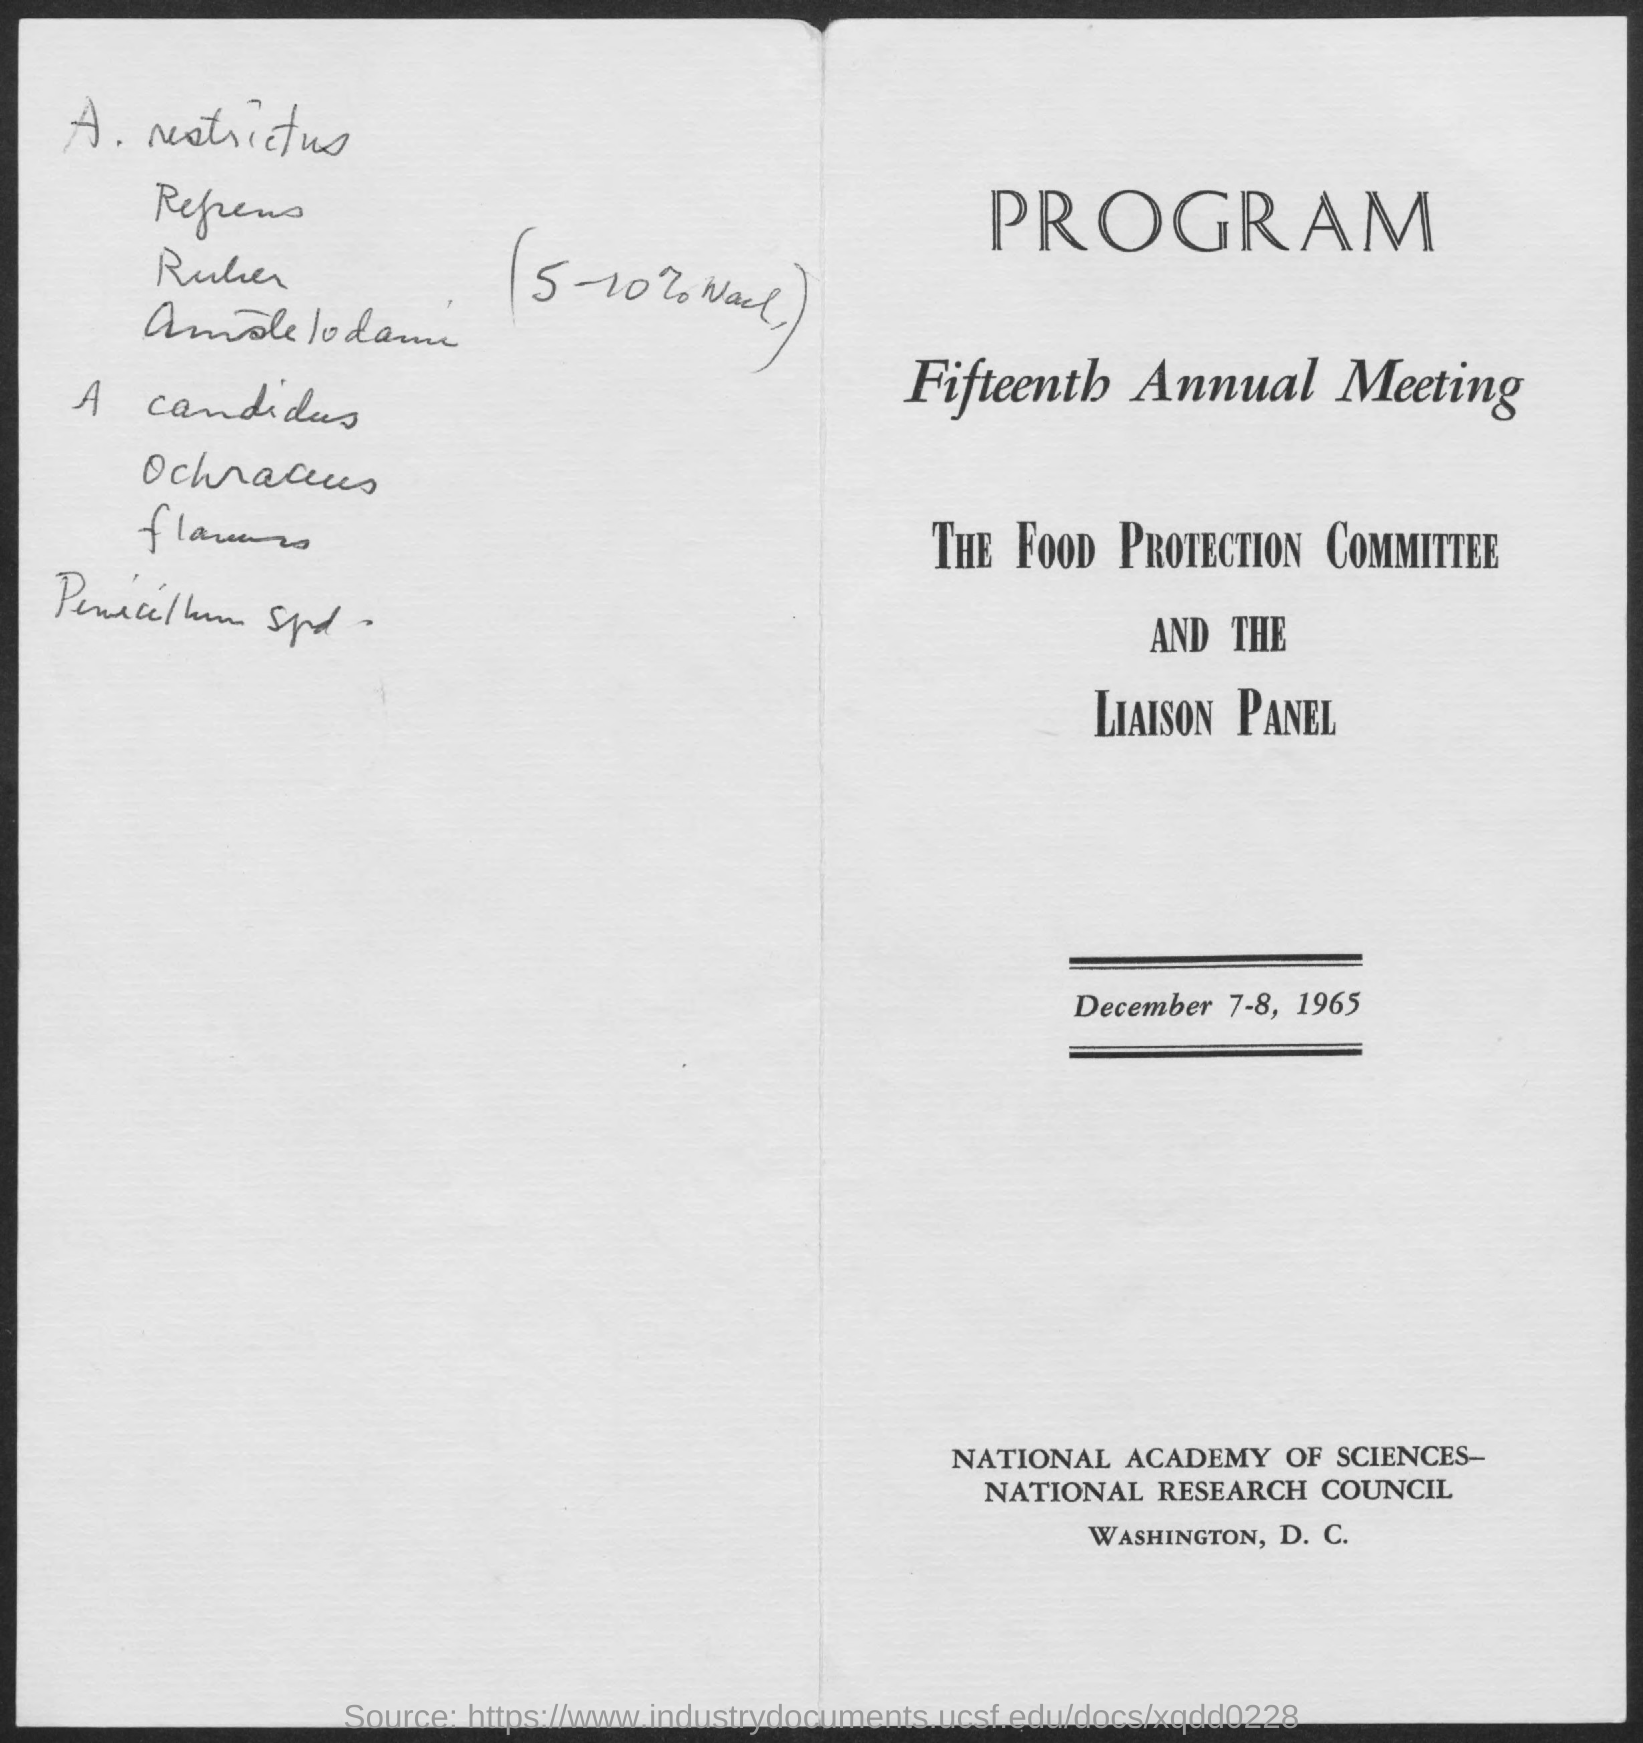What is the date mentioned in the document?
Ensure brevity in your answer.  December 7-8, 1965. 